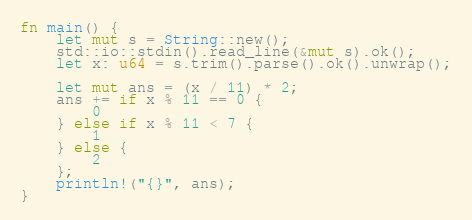Convert code to text. <code><loc_0><loc_0><loc_500><loc_500><_Rust_>fn main() {
    let mut s = String::new();
    std::io::stdin().read_line(&mut s).ok();
    let x: u64 = s.trim().parse().ok().unwrap();

    let mut ans = (x / 11) * 2;
    ans += if x % 11 == 0 {
        0
    } else if x % 11 < 7 {
        1
    } else {
        2
    };
    println!("{}", ans);
}
</code> 